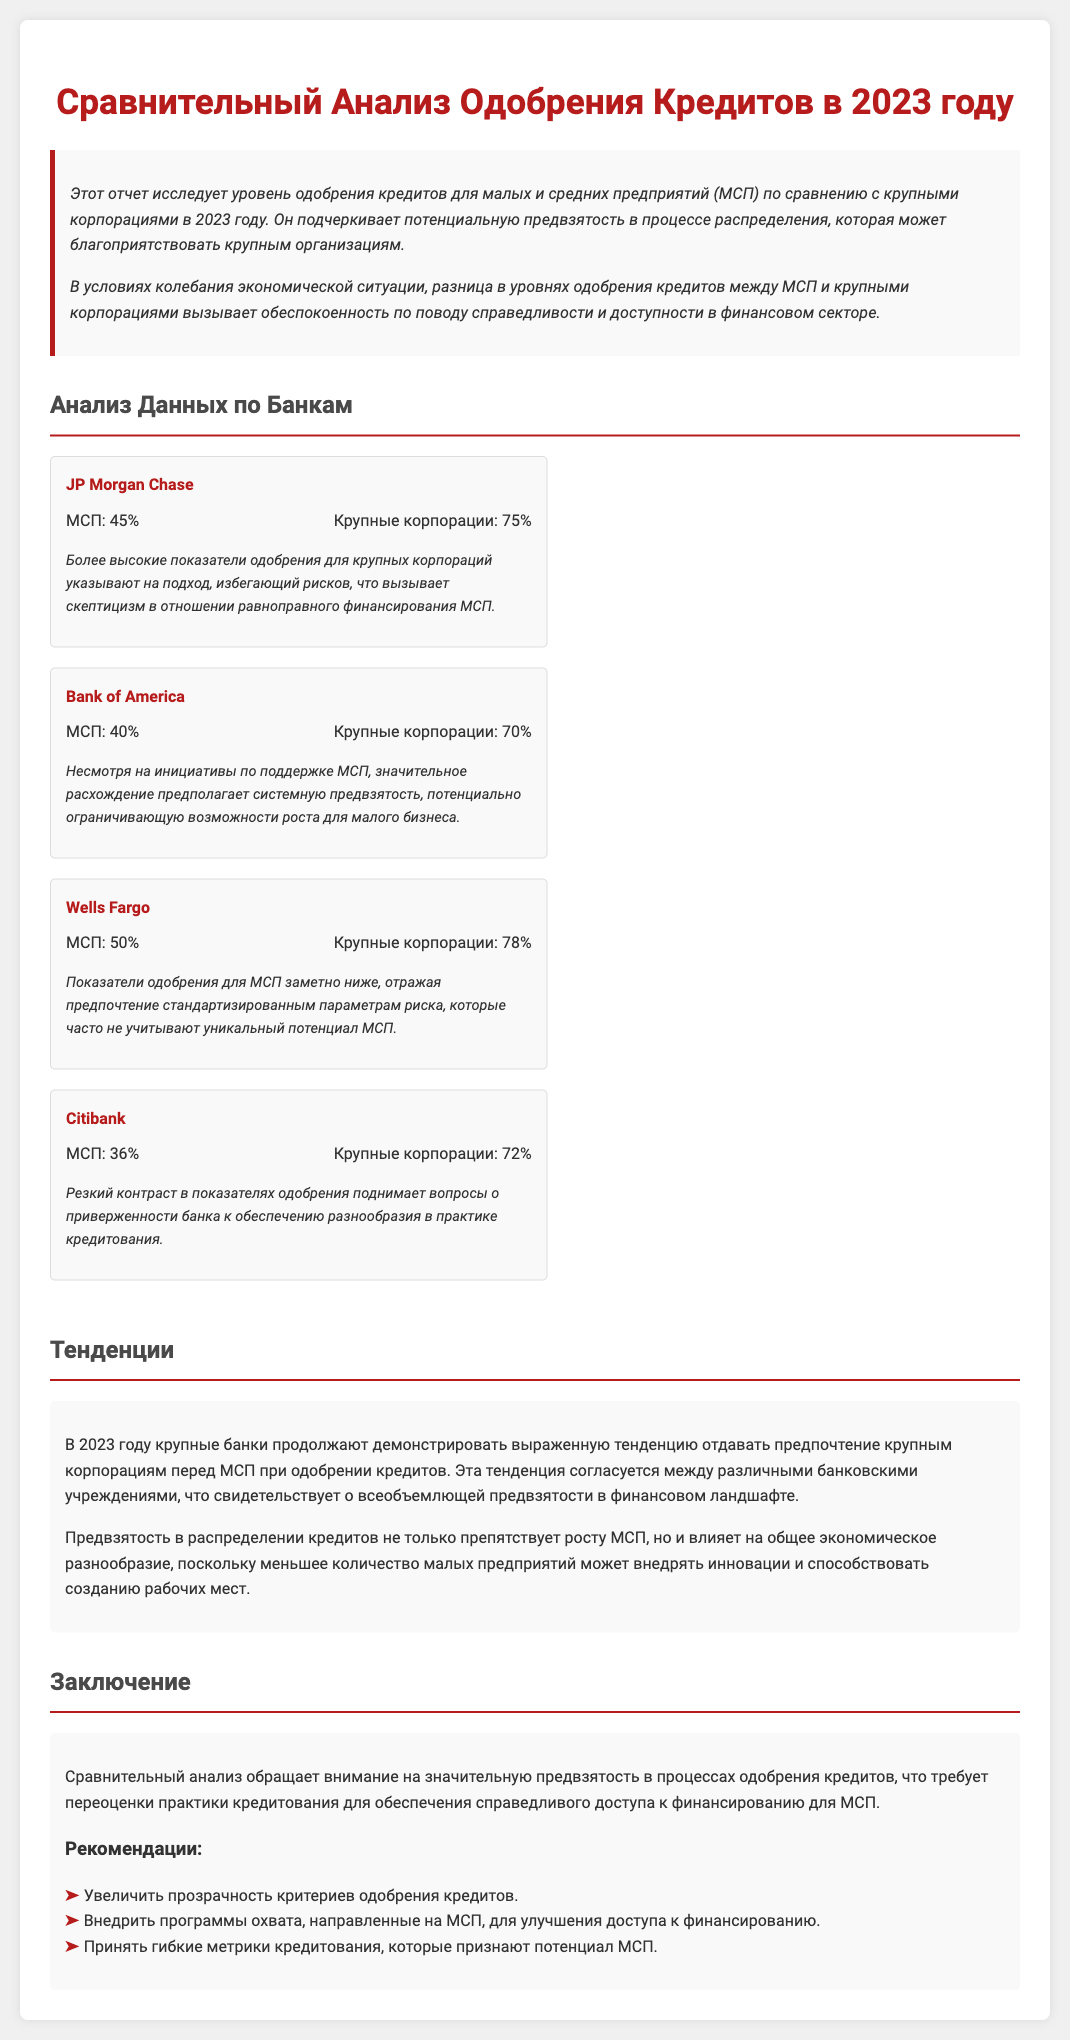What is the loan approval rate for small and medium enterprises at JP Morgan Chase? The loan approval rate for small and medium enterprises at JP Morgan Chase is 45%.
Answer: 45% What is the loan approval rate for large corporations at Citibank? The loan approval rate for large corporations at Citibank is 72%.
Answer: 72% Which bank shows the highest approval rate for large corporations? The bank with the highest approval rate for large corporations is Wells Fargo with 78%.
Answer: Wells Fargo What does the report suggest about the trend in loan approvals for SMEs versus large corporations? The report suggests that there is a preference for large corporations in loan approvals, indicating a bias.
Answer: Preference for large corporations What potential impact does the bias in loan approvals have on small businesses? The bias in loan approvals can hinder the growth of small businesses and affect economic diversity.
Answer: Hinder growth What percentage of loan approval is indicated for small and medium enterprises at Bank of America? The percentage of loan approval for small and medium enterprises at Bank of America is 40%.
Answer: 40% What recommendations does the report make for addressing bias in the loan approval process? The recommendations include increasing transparency in approval criteria and implementing outreach programs for SMEs.
Answer: Increase transparency What key observation is noted regarding Wells Fargo's SME loan approval rates? A key observation is that their approval rates for SMEs are significantly lower, reflecting standardized risk parameters.
Answer: Significantly lower 